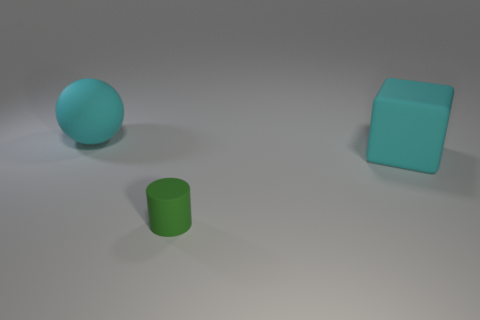Add 2 big things. How many objects exist? 5 Subtract all spheres. How many objects are left? 2 Subtract all cyan matte balls. Subtract all green rubber cylinders. How many objects are left? 1 Add 1 tiny rubber cylinders. How many tiny rubber cylinders are left? 2 Add 3 balls. How many balls exist? 4 Subtract 0 gray spheres. How many objects are left? 3 